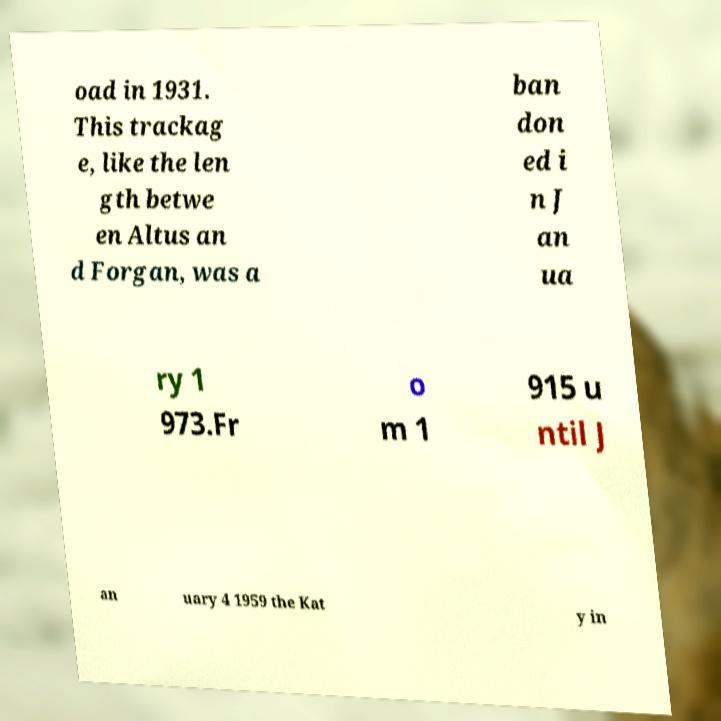Could you extract and type out the text from this image? oad in 1931. This trackag e, like the len gth betwe en Altus an d Forgan, was a ban don ed i n J an ua ry 1 973.Fr o m 1 915 u ntil J an uary 4 1959 the Kat y in 